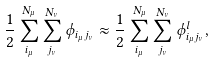Convert formula to latex. <formula><loc_0><loc_0><loc_500><loc_500>\frac { 1 } { 2 } \sum _ { i _ { \mu } } ^ { N _ { \mu } } \sum _ { j _ { \nu } } ^ { N _ { \nu } } \phi _ { i _ { \mu } j _ { \nu } } \approx \frac { 1 } { 2 } \sum _ { i _ { \mu } } ^ { N _ { \mu } } \sum _ { j _ { \nu } } ^ { N _ { \nu } } \phi ^ { l } _ { i _ { \mu } j _ { \nu } } ,</formula> 